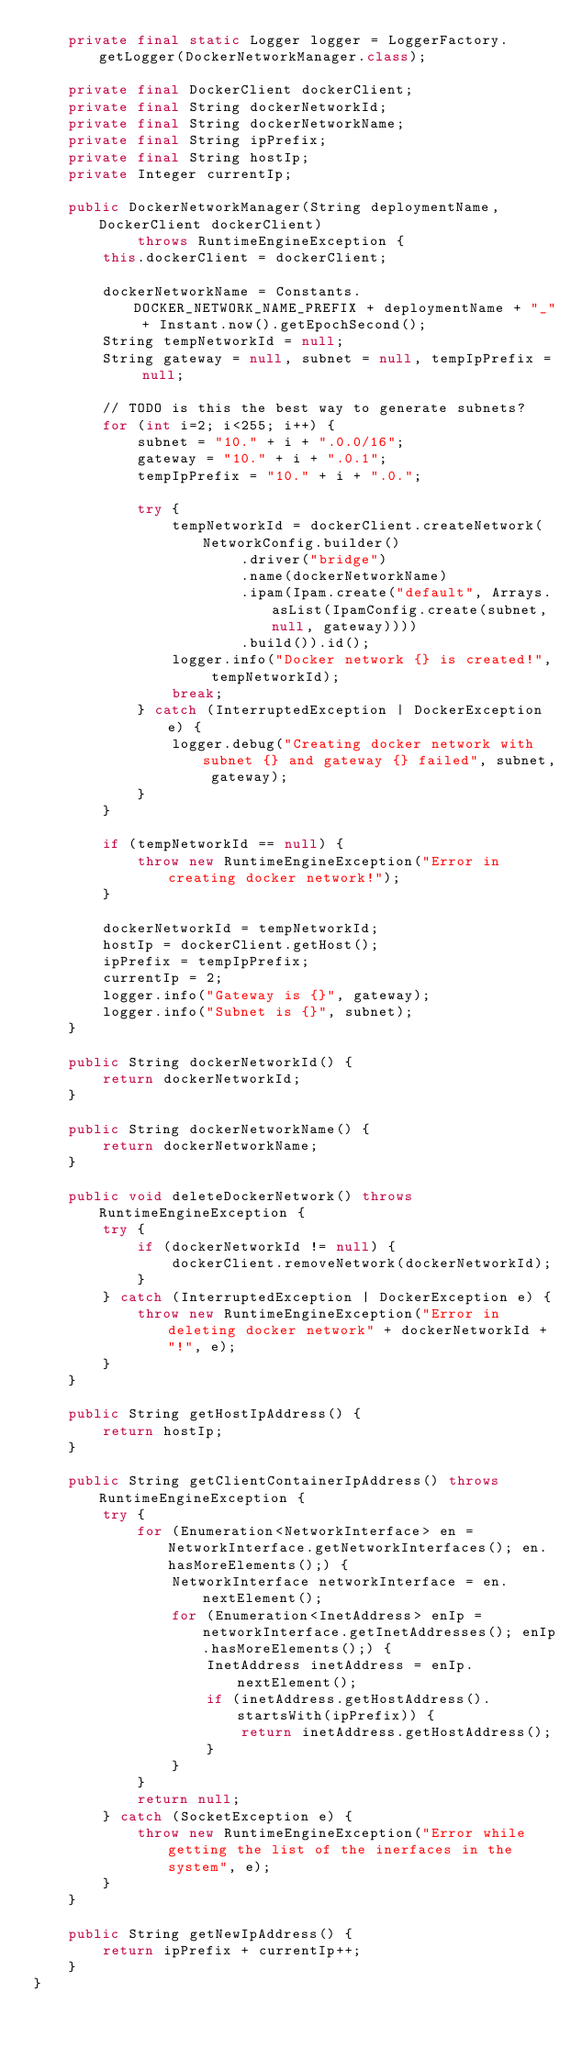<code> <loc_0><loc_0><loc_500><loc_500><_Java_>    private final static Logger logger = LoggerFactory.getLogger(DockerNetworkManager.class);

    private final DockerClient dockerClient;
    private final String dockerNetworkId;
    private final String dockerNetworkName;
    private final String ipPrefix;
    private final String hostIp;
    private Integer currentIp;

    public DockerNetworkManager(String deploymentName, DockerClient dockerClient)
            throws RuntimeEngineException {
        this.dockerClient = dockerClient;

        dockerNetworkName = Constants.DOCKER_NETWORK_NAME_PREFIX + deploymentName + "_" + Instant.now().getEpochSecond();
        String tempNetworkId = null;
        String gateway = null, subnet = null, tempIpPrefix = null;

        // TODO is this the best way to generate subnets?
        for (int i=2; i<255; i++) {
            subnet = "10." + i + ".0.0/16";
            gateway = "10." + i + ".0.1";
            tempIpPrefix = "10." + i + ".0.";

            try {
                tempNetworkId = dockerClient.createNetwork(NetworkConfig.builder()
                        .driver("bridge")
                        .name(dockerNetworkName)
                        .ipam(Ipam.create("default", Arrays.asList(IpamConfig.create(subnet, null, gateway))))
                        .build()).id();
                logger.info("Docker network {} is created!", tempNetworkId);
                break;
            } catch (InterruptedException | DockerException e) {
                logger.debug("Creating docker network with subnet {} and gateway {} failed", subnet, gateway);
            }
        }

        if (tempNetworkId == null) {
            throw new RuntimeEngineException("Error in creating docker network!");
        }

        dockerNetworkId = tempNetworkId;
        hostIp = dockerClient.getHost();
        ipPrefix = tempIpPrefix;
        currentIp = 2;
        logger.info("Gateway is {}", gateway);
        logger.info("Subnet is {}", subnet);
    }

    public String dockerNetworkId() {
        return dockerNetworkId;
    }

    public String dockerNetworkName() {
        return dockerNetworkName;
    }

    public void deleteDockerNetwork() throws RuntimeEngineException {
        try {
            if (dockerNetworkId != null) {
                dockerClient.removeNetwork(dockerNetworkId);
            }
        } catch (InterruptedException | DockerException e) {
            throw new RuntimeEngineException("Error in deleting docker network" + dockerNetworkId + "!", e);
        }
    }

    public String getHostIpAddress() {
        return hostIp;
    }

    public String getClientContainerIpAddress() throws RuntimeEngineException {
        try {
            for (Enumeration<NetworkInterface> en = NetworkInterface.getNetworkInterfaces(); en.hasMoreElements();) {
                NetworkInterface networkInterface = en.nextElement();
                for (Enumeration<InetAddress> enIp = networkInterface.getInetAddresses(); enIp.hasMoreElements();) {
                    InetAddress inetAddress = enIp.nextElement();
                    if (inetAddress.getHostAddress().startsWith(ipPrefix)) {
                        return inetAddress.getHostAddress();
                    }
                }
            }
            return null;
        } catch (SocketException e) {
            throw new RuntimeEngineException("Error while getting the list of the inerfaces in the system", e);
        }
    }

    public String getNewIpAddress() {
        return ipPrefix + currentIp++;
    }
}
</code> 